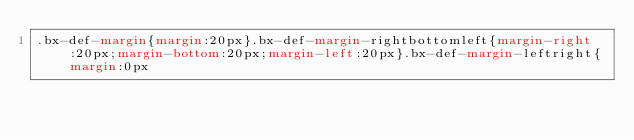<code> <loc_0><loc_0><loc_500><loc_500><_CSS_>.bx-def-margin{margin:20px}.bx-def-margin-rightbottomleft{margin-right:20px;margin-bottom:20px;margin-left:20px}.bx-def-margin-leftright{margin:0px</code> 